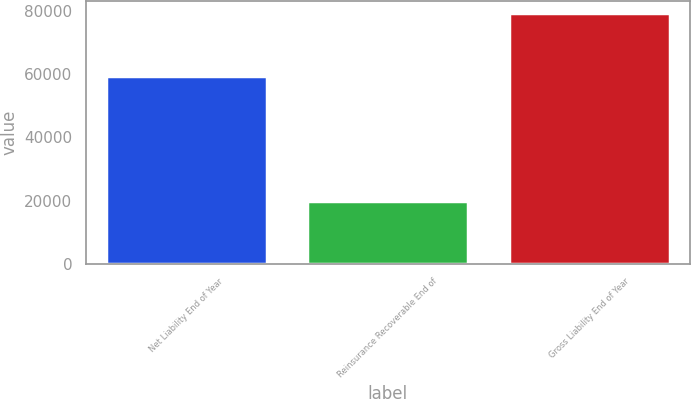<chart> <loc_0><loc_0><loc_500><loc_500><bar_chart><fcel>Net Liability End of Year<fcel>Reinsurance Recoverable End of<fcel>Gross Liability End of Year<nl><fcel>59586<fcel>19693<fcel>79279<nl></chart> 